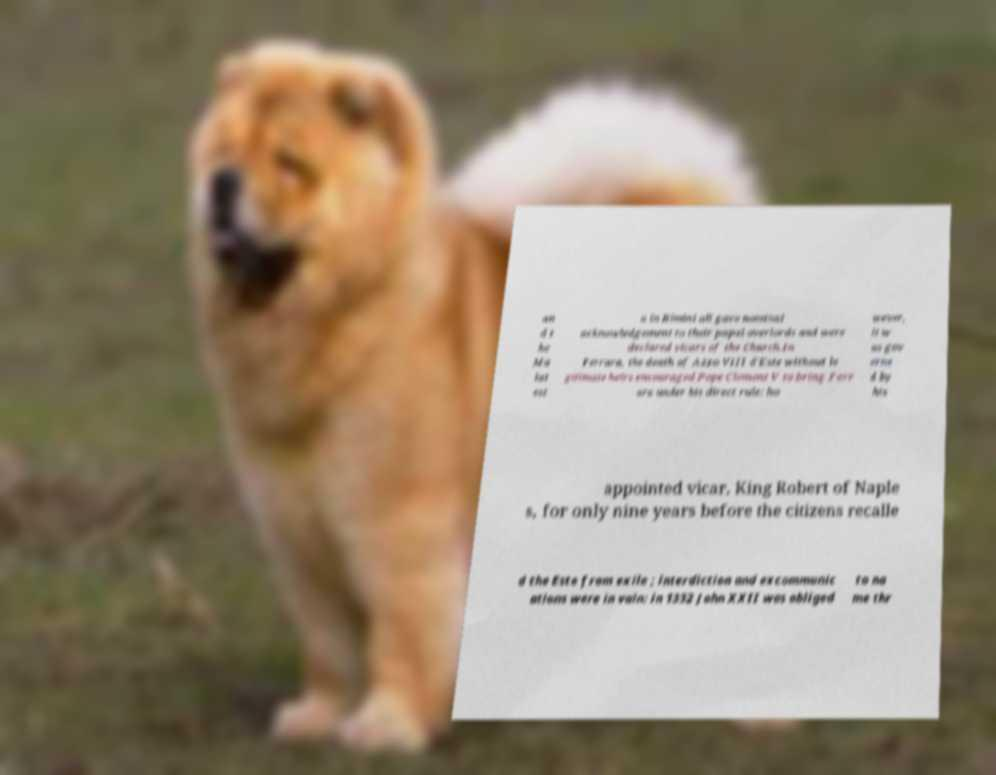I need the written content from this picture converted into text. Can you do that? an d t he Ma lat est a in Rimini all gave nominal acknowledgement to their papal overlords and were declared vicars of the Church.In Ferrara, the death of Azzo VIII d'Este without le gitimate heirs encouraged Pope Clement V to bring Ferr ara under his direct rule: ho wever, it w as gov erne d by his appointed vicar, King Robert of Naple s, for only nine years before the citizens recalle d the Este from exile ; interdiction and excommunic ations were in vain: in 1332 John XXII was obliged to na me thr 